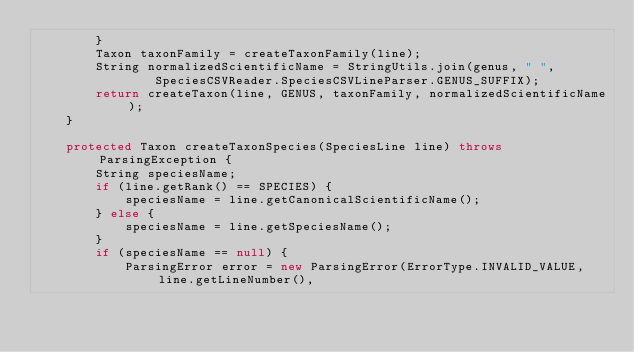Convert code to text. <code><loc_0><loc_0><loc_500><loc_500><_Java_>		}
		Taxon taxonFamily = createTaxonFamily(line);
		String normalizedScientificName = StringUtils.join(genus, " ",
				SpeciesCSVReader.SpeciesCSVLineParser.GENUS_SUFFIX);
		return createTaxon(line, GENUS, taxonFamily, normalizedScientificName);
	}

	protected Taxon createTaxonSpecies(SpeciesLine line) throws ParsingException {
		String speciesName;
		if (line.getRank() == SPECIES) {
			speciesName = line.getCanonicalScientificName();
		} else {
			speciesName = line.getSpeciesName();
		}
		if (speciesName == null) {
			ParsingError error = new ParsingError(ErrorType.INVALID_VALUE, line.getLineNumber(),</code> 